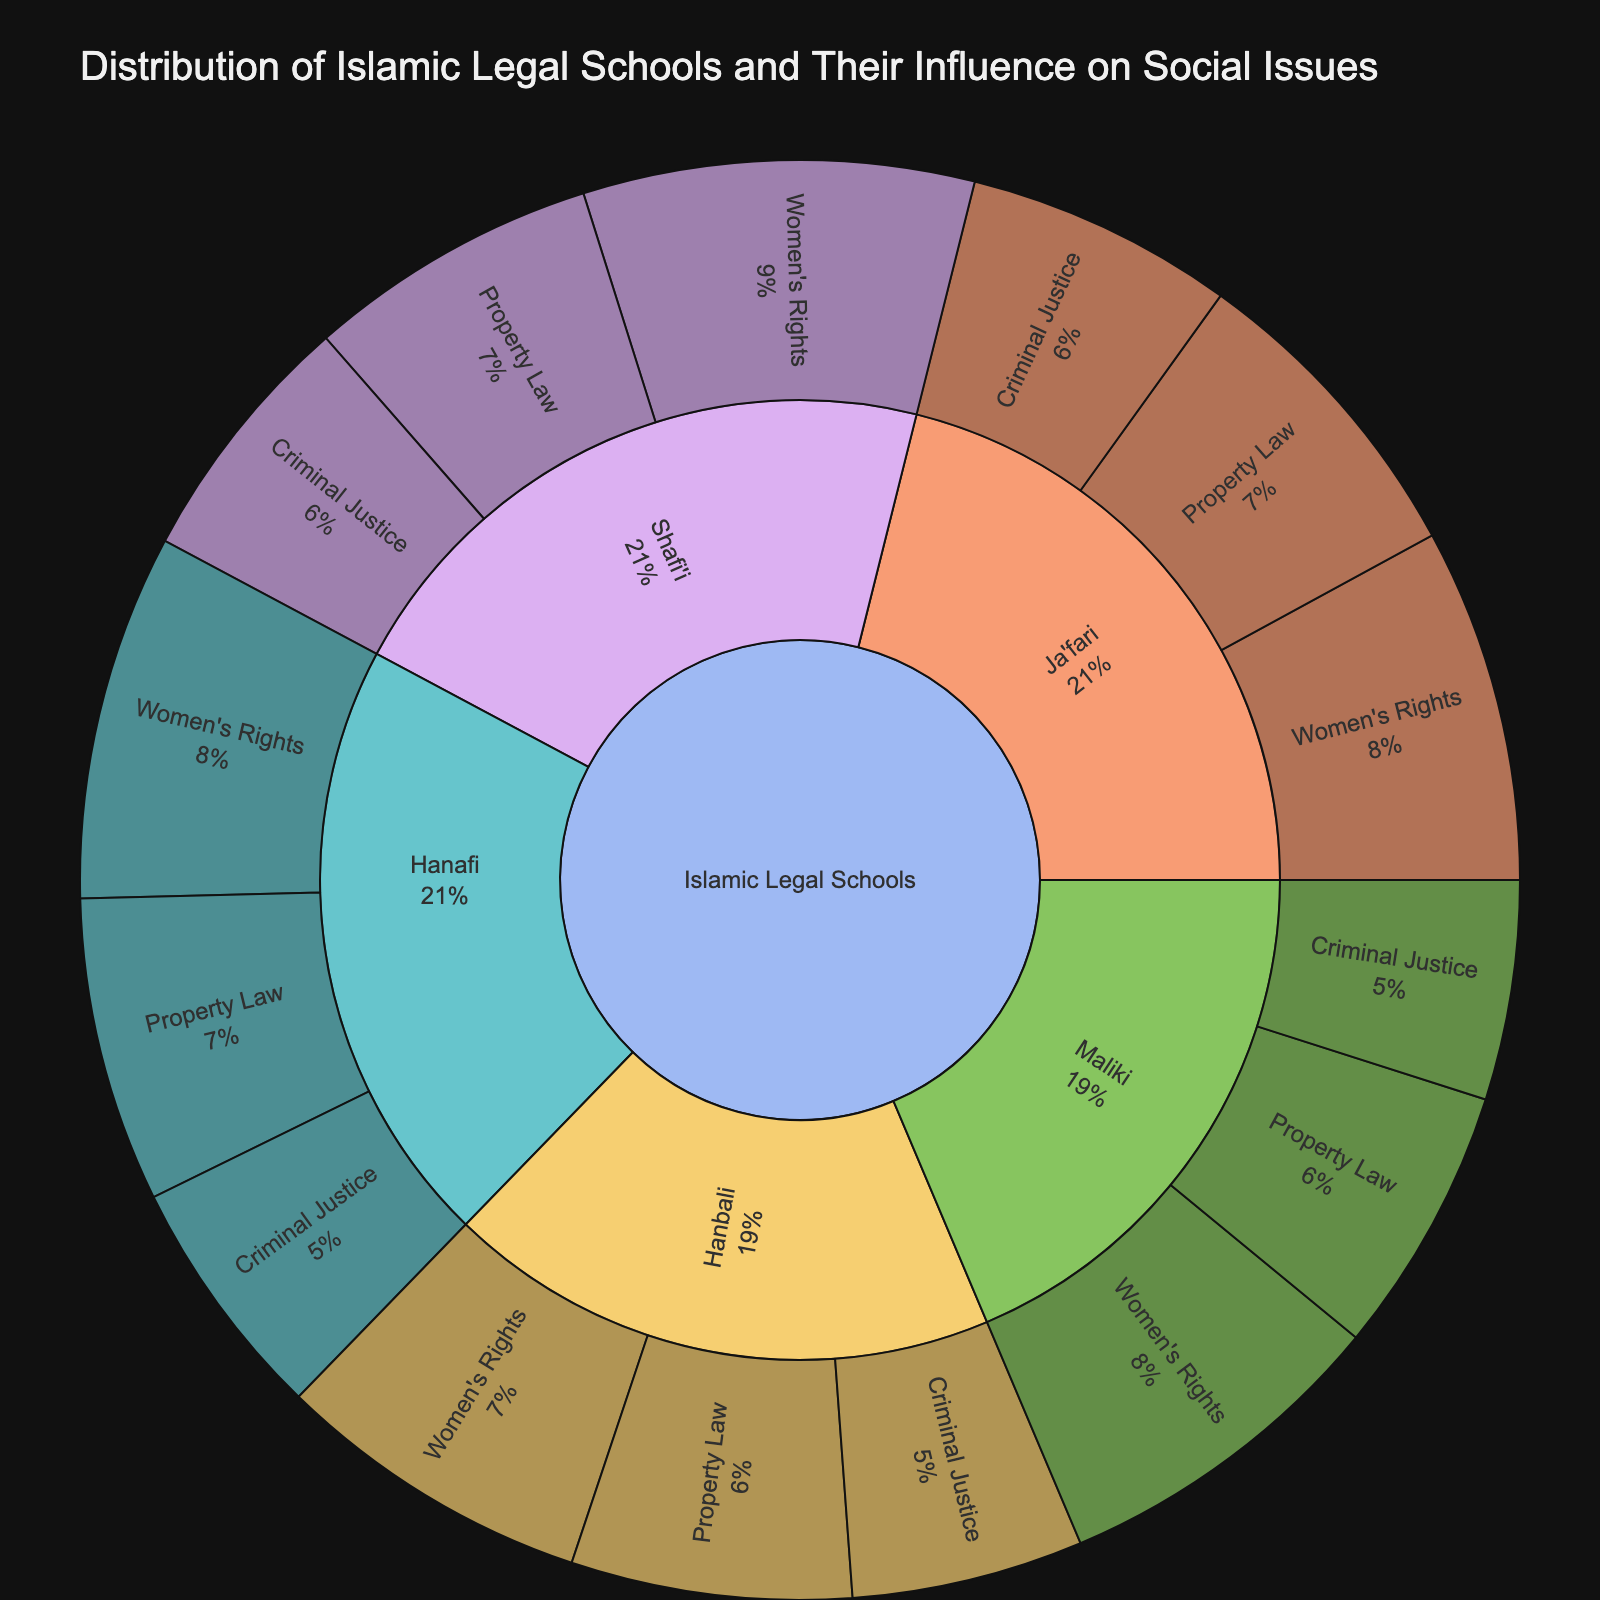Which Islamic legal school has the highest value for Women's Rights? Observe the values for Women's Rights in all the legal schools. Shafi'i has the highest value at 32.
Answer: Shafi'i What is the total influence value of the Hanafi legal school on all three social issues? Summing up the values for Women's Rights, Property Law, and Criminal Justice within the Hanafi legal school: 30 (Women's Rights) + 25 (Property Law) + 20 (Criminal Justice) equals 75.
Answer: 75 Which issue does the Ja'fari school have the highest influence on? Compare the values of Women's Rights, Property Law, and Criminal Justice within the Ja'fari school. Property Law has the highest value at 26.
Answer: Property Law How does the influence of the Maliki school on Criminal Justice compare to that of the Ja'fari school? Compare the values for Criminal Justice: Maliki has 18 and Ja'fari has 22. Ja'fari's influence is higher.
Answer: Ja'fari Which Islamic legal school has the least influence on Property Law? Compare the Property Law values across Hanafi, Maliki, Shafi'i, Hanbali, and Ja'fari schools. Maliki has the lowest value at 22.
Answer: Maliki What is the average influence of the Shafi'i legal school on the three social issues? Sum the values for Women's Rights, Property Law, and Criminal Justice within the Shafi'i school (32 + 24 + 21) and divide by 3. The sum is 77, so the average is 77/3 = 25.67.
Answer: 25.67 What is the total influence of all Islamic legal schools on Women's Rights? Add the Women's Rights values for all legal schools: 30 (Hanafi) + 28 (Maliki) + 32 (Shafi'i) + 26 (Hanbali) + 29 (Ja'fari). The total is 145.
Answer: 145 How does the influence of Hanafi on Property Law compare to that of Hanbali on the same issue? Compare the values for Property Law in both Hanafi and Hanbali: Hanafi has 25 and Hanbali has 23. Hanafi's influence is higher.
Answer: Hanafi Which social issue does the Hanbali school have its lowest influence on? Compare the values of Women's Rights, Property Law, and Criminal Justice within the Hanbali school. The lowest is Criminal Justice at 19.
Answer: Criminal Justice 